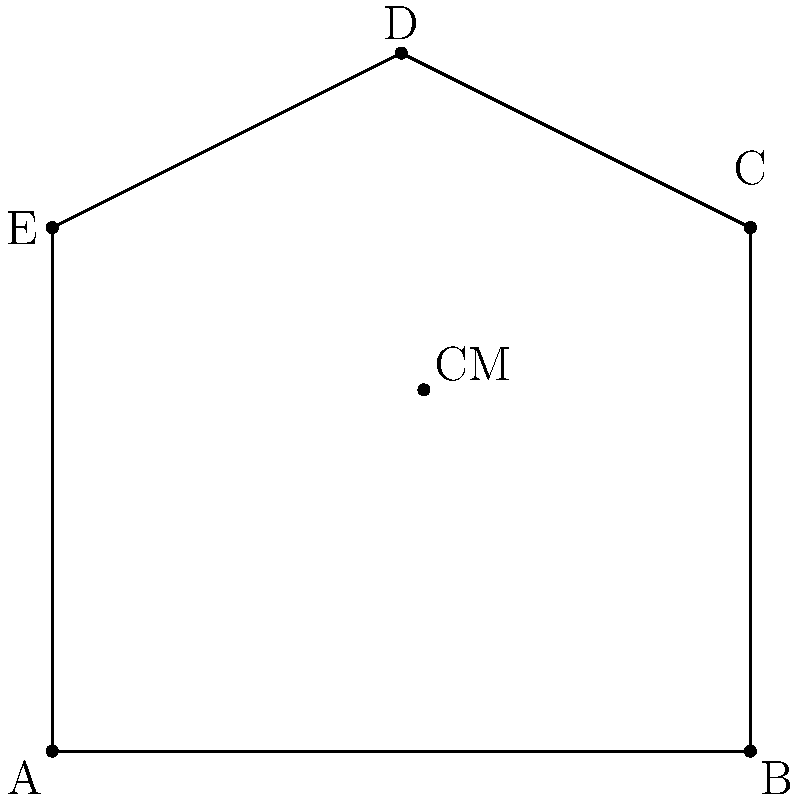You've just restored an irregularly shaped artifact represented by the pentagonal plate ABCDE. Given that the center of mass (CM) is located at coordinates (2.13, 2.07), calculate the moment of inertia of the plate about an axis passing through point A, perpendicular to the plane. Assume the plate has a uniform density of 2.5 g/cm² and use g = 9.8 m/s². To solve this problem, we'll follow these steps:

1) First, we need to calculate the area of the pentagonal plate. We can do this by dividing it into a rectangle and a triangle:
   Area = Area of rectangle ABCE + Area of triangle CDE
   $$A = (4 * 3) + (0.5 * 2 * 1) = 13 \text{ cm}^2$$

2) Now we can calculate the mass of the plate:
   $$m = \text{density} * \text{area} = 2.5 \text{ g/cm}^2 * 13 \text{ cm}^2 = 32.5 \text{ g} = 0.0325 \text{ kg}$$

3) The moment of inertia about the center of mass is given by:
   $$I_{CM} = \frac{1}{12}m(a^2 + b^2)$$
   where a and b are the dimensions of the plate. We can approximate this as:
   $$I_{CM} \approx \frac{1}{12} * 0.0325 * (4^2 + 4^2) = 0.0433 \text{ kg}\cdot\text{m}^2$$

4) To find the moment of inertia about point A, we use the parallel axis theorem:
   $$I_A = I_{CM} + md^2$$
   where d is the distance from A to CM.

5) Calculate d:
   $$d = \sqrt{(2.13-0)^2 + (2.07-0)^2} = 2.97 \text{ cm} = 0.0297 \text{ m}$$

6) Now we can calculate $I_A$:
   $$I_A = 0.0433 + 0.0325 * 0.0297^2 = 0.0433 + 0.0000287 = 0.0433287 \text{ kg}\cdot\text{m}^2$$
Answer: $0.0433 \text{ kg}\cdot\text{m}^2$ 